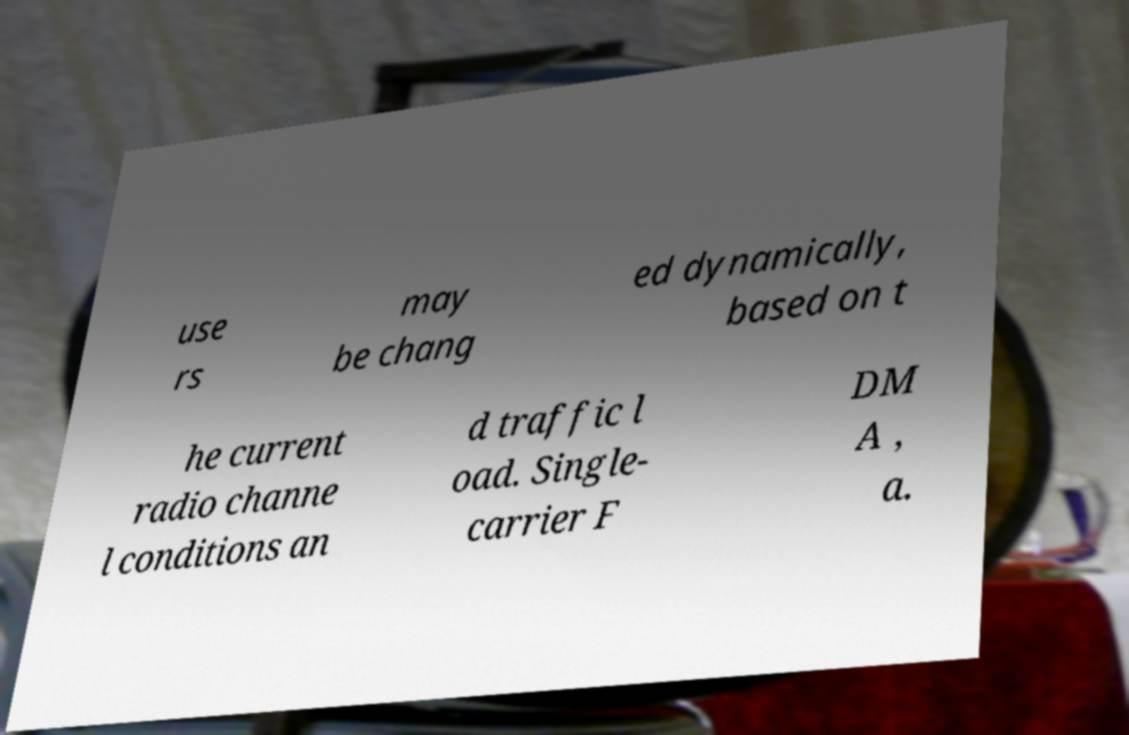What messages or text are displayed in this image? I need them in a readable, typed format. use rs may be chang ed dynamically, based on t he current radio channe l conditions an d traffic l oad. Single- carrier F DM A , a. 